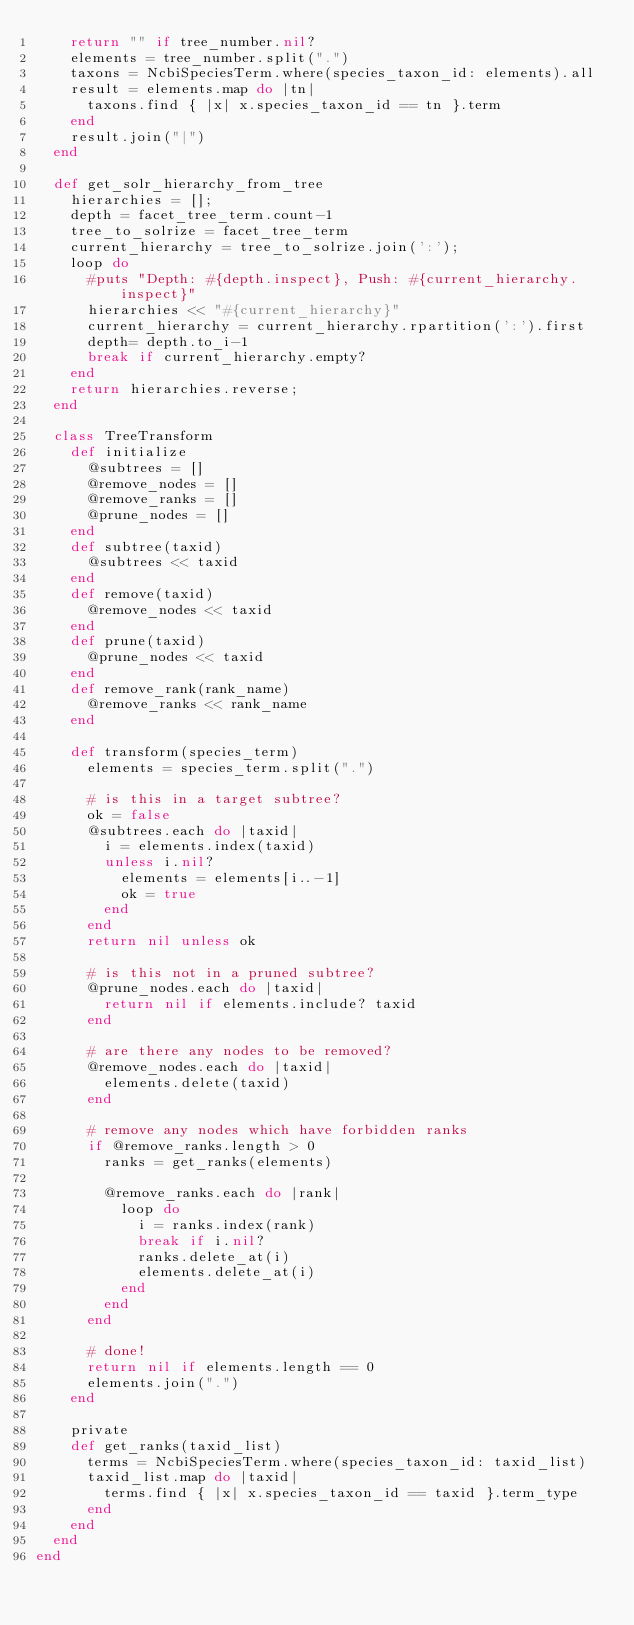<code> <loc_0><loc_0><loc_500><loc_500><_Ruby_>    return "" if tree_number.nil?
    elements = tree_number.split(".")
    taxons = NcbiSpeciesTerm.where(species_taxon_id: elements).all
    result = elements.map do |tn|
      taxons.find { |x| x.species_taxon_id == tn }.term
    end
    result.join("|")
  end

  def get_solr_hierarchy_from_tree
    hierarchies = [];
    depth = facet_tree_term.count-1
    tree_to_solrize = facet_tree_term
    current_hierarchy = tree_to_solrize.join(':');
    loop do
      #puts "Depth: #{depth.inspect}, Push: #{current_hierarchy.inspect}"
      hierarchies << "#{current_hierarchy}"
      current_hierarchy = current_hierarchy.rpartition(':').first
      depth= depth.to_i-1
      break if current_hierarchy.empty?
    end
    return hierarchies.reverse;
  end

  class TreeTransform
    def initialize
      @subtrees = []
      @remove_nodes = []
      @remove_ranks = []
      @prune_nodes = []
    end
    def subtree(taxid)
      @subtrees << taxid
    end
    def remove(taxid)
      @remove_nodes << taxid
    end
    def prune(taxid)
      @prune_nodes << taxid
    end
    def remove_rank(rank_name)
      @remove_ranks << rank_name
    end

    def transform(species_term)
      elements = species_term.split(".")

      # is this in a target subtree?
      ok = false
      @subtrees.each do |taxid|
        i = elements.index(taxid)
        unless i.nil?
          elements = elements[i..-1]
          ok = true
        end
      end
      return nil unless ok

      # is this not in a pruned subtree?
      @prune_nodes.each do |taxid|
        return nil if elements.include? taxid
      end

      # are there any nodes to be removed?
      @remove_nodes.each do |taxid|
        elements.delete(taxid)
      end

      # remove any nodes which have forbidden ranks
      if @remove_ranks.length > 0
        ranks = get_ranks(elements)

        @remove_ranks.each do |rank|
          loop do
            i = ranks.index(rank)
            break if i.nil?
            ranks.delete_at(i)
            elements.delete_at(i)
          end
        end
      end

      # done!
      return nil if elements.length == 0
      elements.join(".")
    end

    private
    def get_ranks(taxid_list)
      terms = NcbiSpeciesTerm.where(species_taxon_id: taxid_list)
      taxid_list.map do |taxid|
        terms.find { |x| x.species_taxon_id == taxid }.term_type
      end
    end
  end
end
</code> 